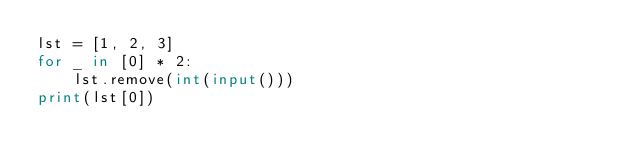<code> <loc_0><loc_0><loc_500><loc_500><_Python_>lst = [1, 2, 3]
for _ in [0] * 2:
    lst.remove(int(input()))
print(lst[0])</code> 